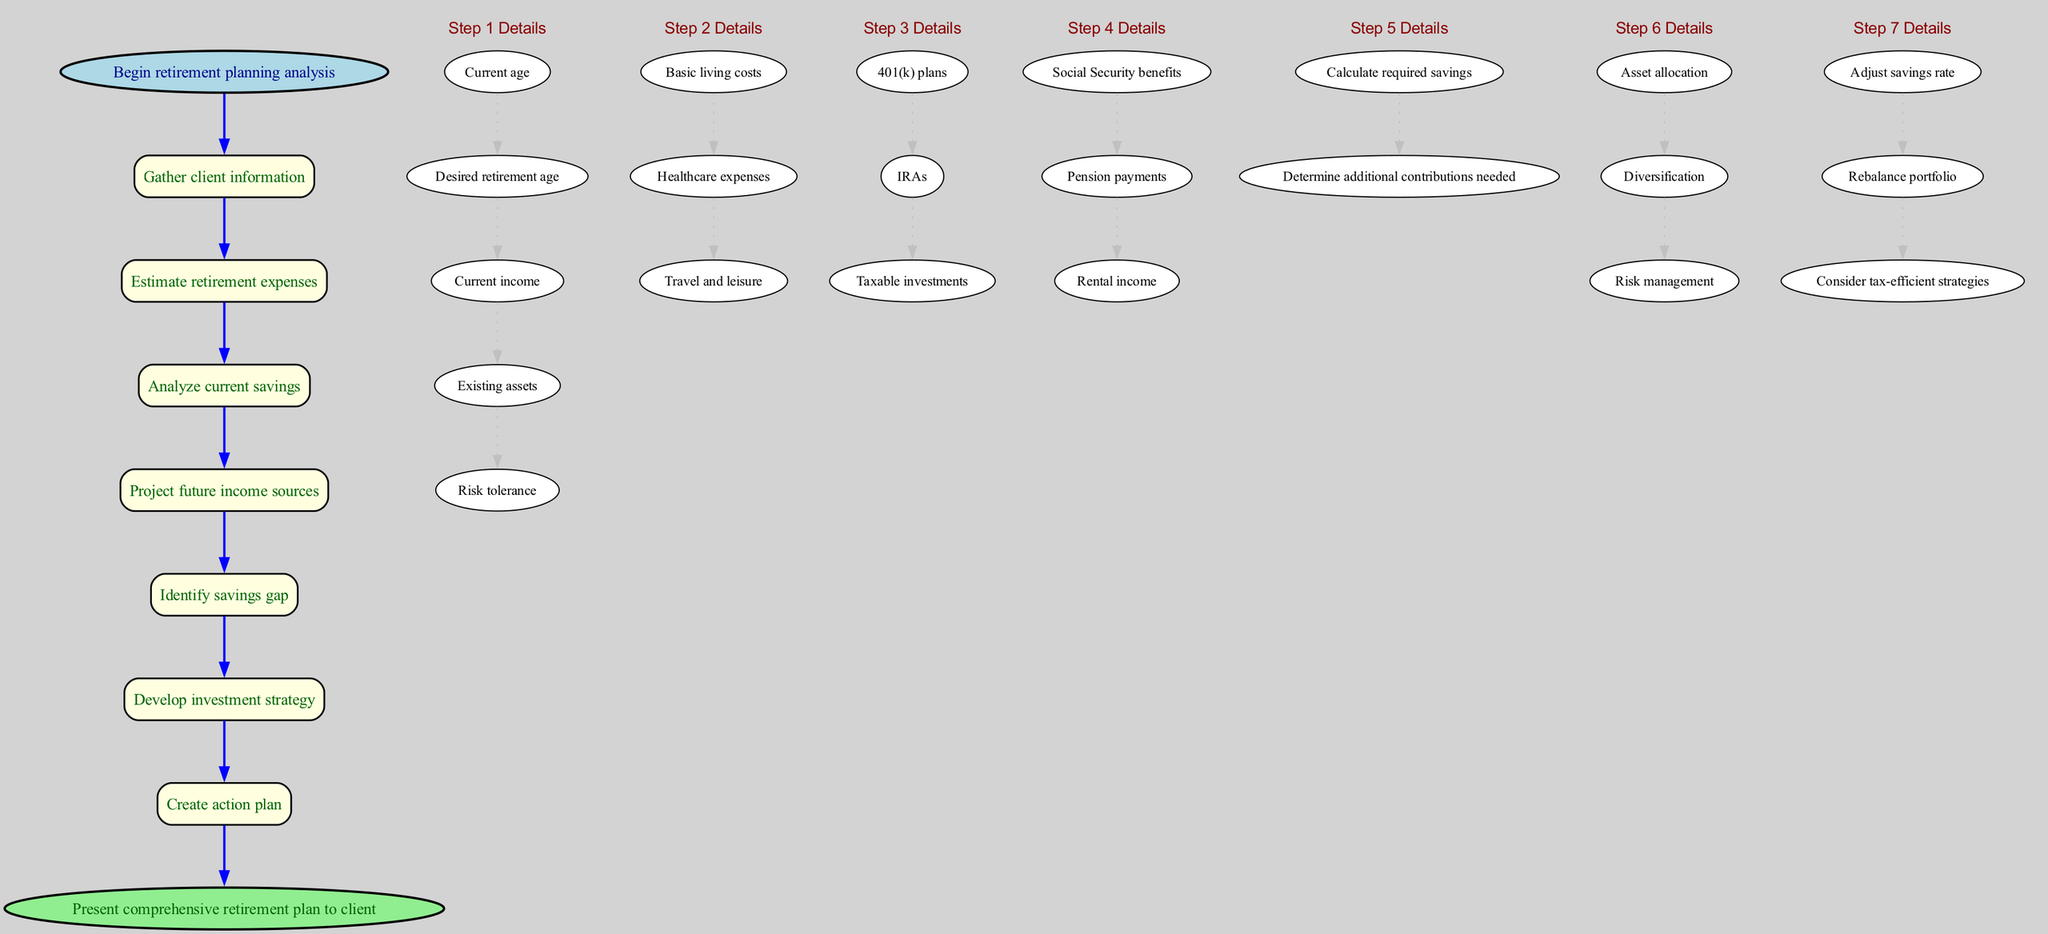What is the first step in the retirement planning analysis? The diagram indicates that the first step is "Gather client information," as noted in the first node after the start node.
Answer: Gather client information How many substeps are listed under "Estimate retirement expenses"? By reviewing the subgraph for the "Estimate retirement expenses" step, we can count three substeps: "Basic living costs," "Healthcare expenses," and "Travel and leisure."
Answer: 3 What connects "Analyze current savings" to "Project future income sources"? The edge connecting those nodes shows a direct relationship, indicating that "Analyze current savings" precedes "Project future income sources," thus establishing a flow in the analysis process.
Answer: blue edge What is the last step in the analysis? The final node in the flow chart, connected from the last step "Create action plan," indicates that the last step is "Present comprehensive retirement plan to client."
Answer: Present comprehensive retirement plan to client Which step includes "Asset allocation" as a substep? In reviewing the diagram, "Asset allocation" appears under the "Develop investment strategy" step, confirming that this substep is part of that broader step.
Answer: Develop investment strategy How many main steps are there in the retirement planning analysis? By counting the nodes representing each step in the main flow (excluding substeps), we see there are a total of six main steps shown in the diagram.
Answer: 6 What do the substeps under "Identify savings gap" focus on? The substeps listed under "Identify savings gap" include "Calculate required savings" and "Determine additional contributions needed," indicating a focus on financial gap assessment.
Answer: Calculate required savings, Determine additional contributions needed Which step directly follows "Project future income sources"? The diagram highlights the direct flow from "Project future income sources" to "Identify savings gap," indicating that this is the next step in the analysis process.
Answer: Identify savings gap What is the shape of the nodes representing the main steps? The nodes representing the main steps are shown in a rectangular shape with rounded corners, as specified in the diagram formatting.
Answer: rounded rectangle 